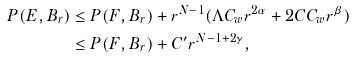Convert formula to latex. <formula><loc_0><loc_0><loc_500><loc_500>P ( E , B _ { r } ) & \leq P ( F , B _ { r } ) + r ^ { N - 1 } ( { \Lambda C _ { w } } r ^ { 2 \alpha } + 2 C C _ { w } r ^ { \beta } ) \\ & \leq P ( F , B _ { r } ) + C ^ { \prime } r ^ { N - 1 + 2 \gamma } ,</formula> 